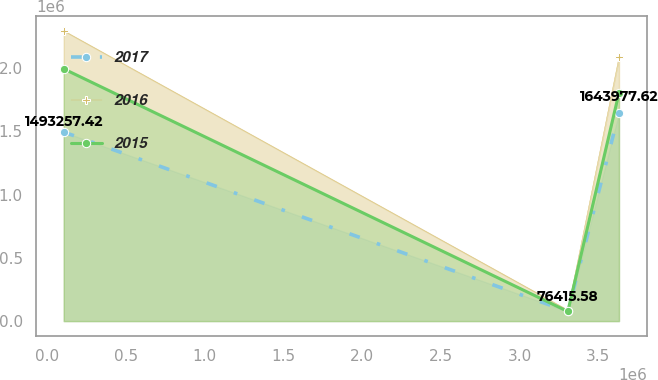<chart> <loc_0><loc_0><loc_500><loc_500><line_chart><ecel><fcel>2017<fcel>2016<fcel>2015<nl><fcel>105812<fcel>1.49326e+06<fcel>2.29344e+06<fcel>1.99258e+06<nl><fcel>3.30579e+06<fcel>76415.6<fcel>87186.9<fcel>75996.5<nl><fcel>3.63069e+06<fcel>1.64398e+06<fcel>2.08376e+06<fcel>1.80369e+06<nl></chart> 